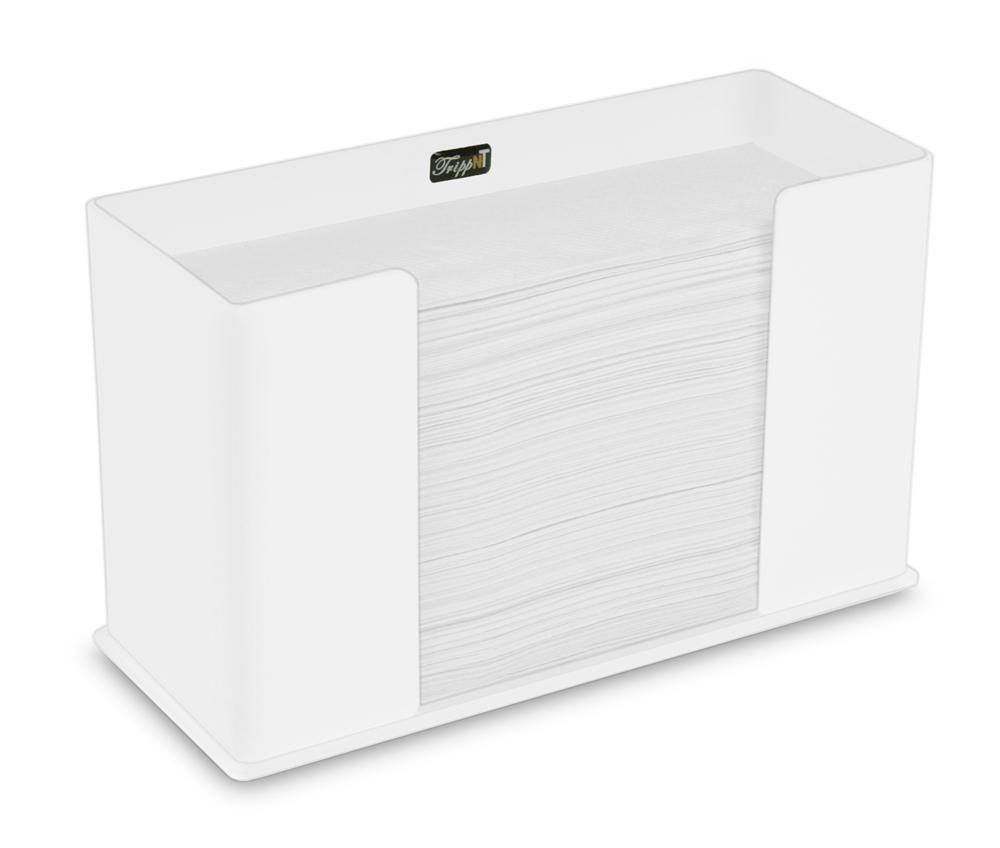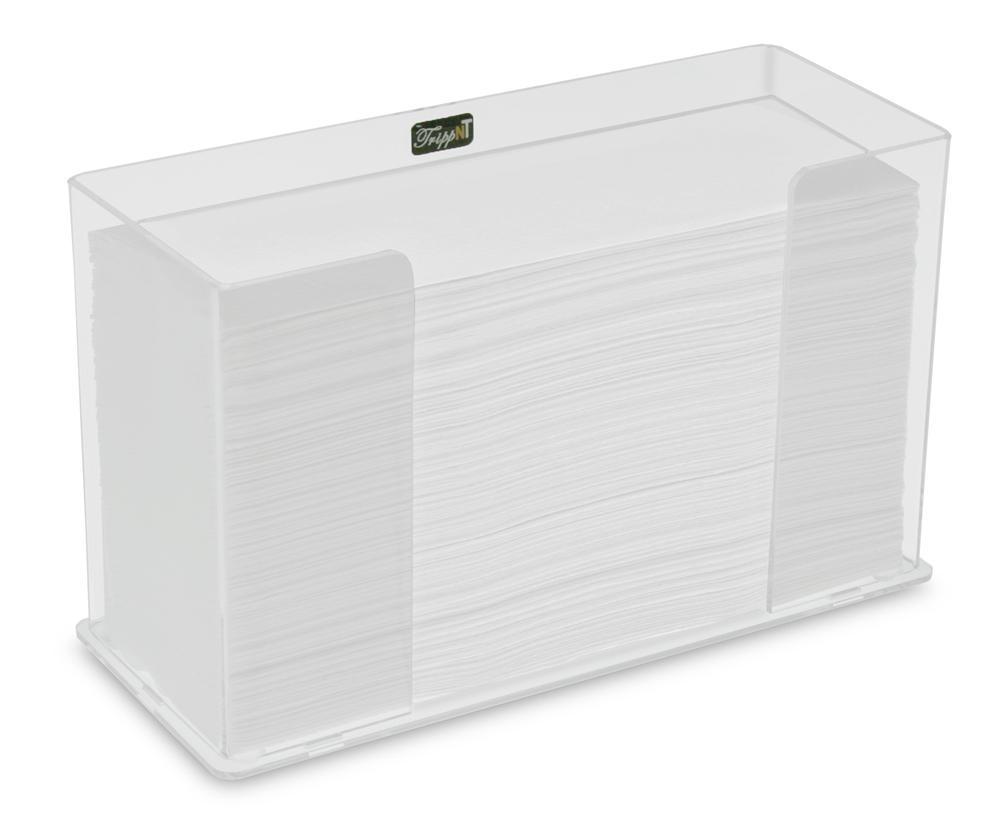The first image is the image on the left, the second image is the image on the right. Evaluate the accuracy of this statement regarding the images: "Both dispensers are rectangular in shape.". Is it true? Answer yes or no. Yes. The first image is the image on the left, the second image is the image on the right. Evaluate the accuracy of this statement regarding the images: "Each image shows a rectangular tray-type container holding a stack of folded paper towels.". Is it true? Answer yes or no. Yes. 